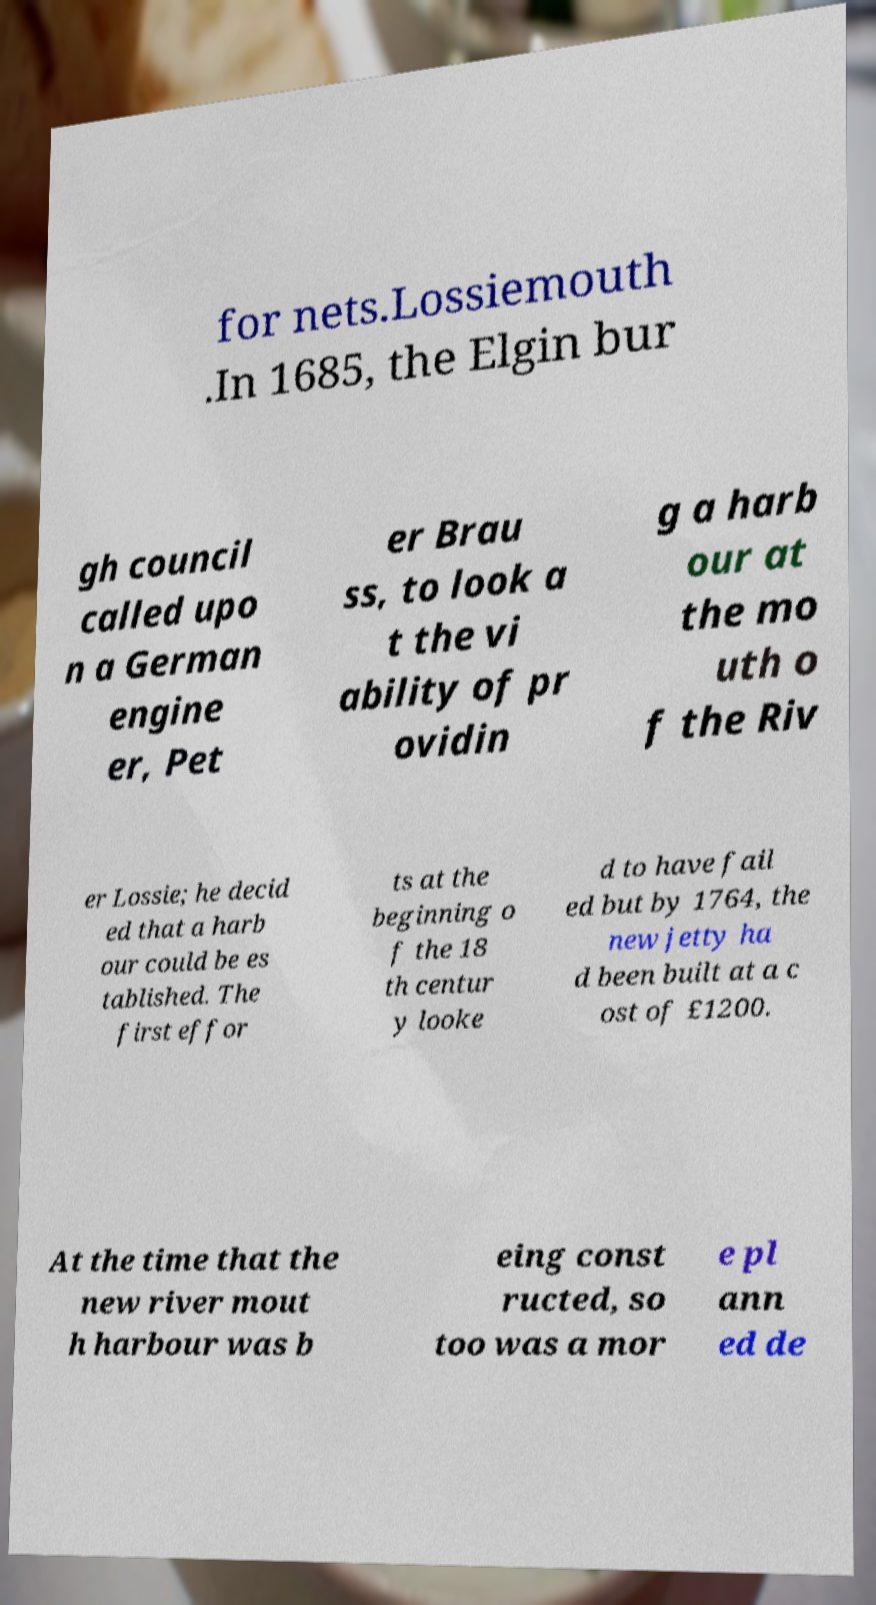Please read and relay the text visible in this image. What does it say? for nets.Lossiemouth .In 1685, the Elgin bur gh council called upo n a German engine er, Pet er Brau ss, to look a t the vi ability of pr ovidin g a harb our at the mo uth o f the Riv er Lossie; he decid ed that a harb our could be es tablished. The first effor ts at the beginning o f the 18 th centur y looke d to have fail ed but by 1764, the new jetty ha d been built at a c ost of £1200. At the time that the new river mout h harbour was b eing const ructed, so too was a mor e pl ann ed de 